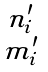Convert formula to latex. <formula><loc_0><loc_0><loc_500><loc_500>\begin{smallmatrix} n ^ { \prime } _ { i } \\ m _ { i } ^ { \prime } \end{smallmatrix}</formula> 